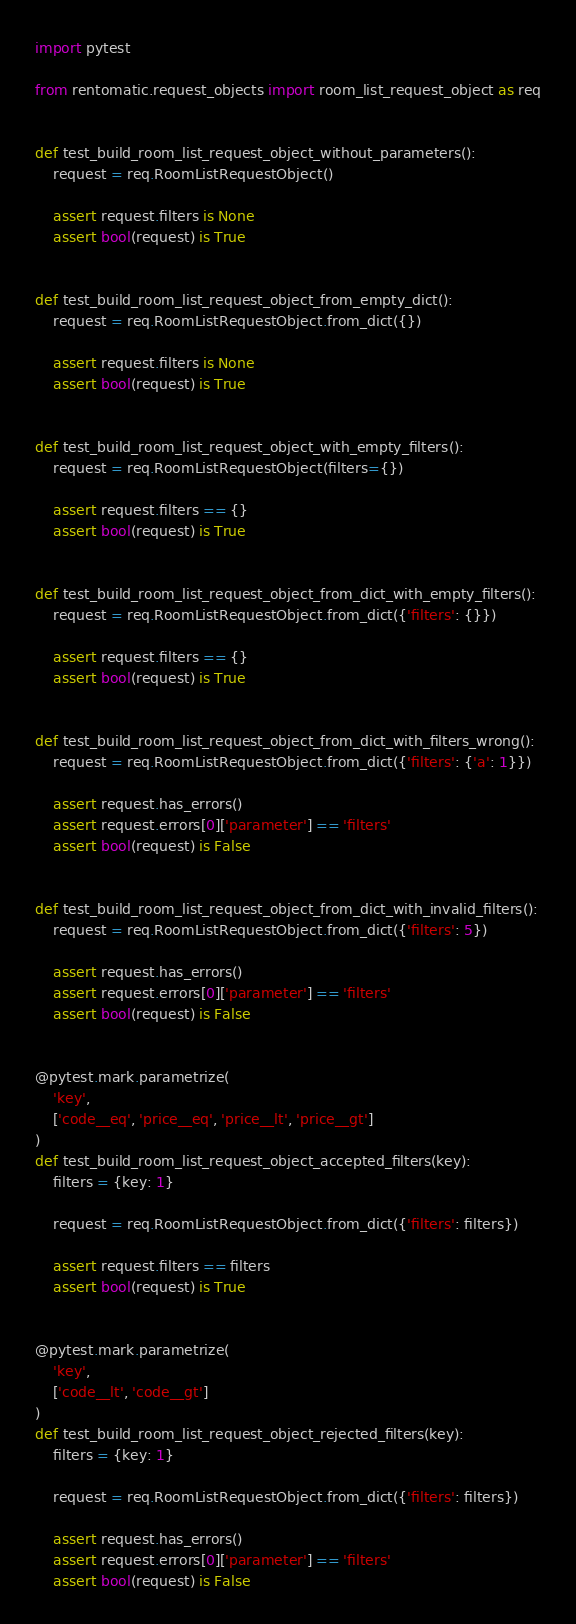Convert code to text. <code><loc_0><loc_0><loc_500><loc_500><_Python_>import pytest

from rentomatic.request_objects import room_list_request_object as req


def test_build_room_list_request_object_without_parameters():
    request = req.RoomListRequestObject()

    assert request.filters is None
    assert bool(request) is True


def test_build_room_list_request_object_from_empty_dict():
    request = req.RoomListRequestObject.from_dict({})

    assert request.filters is None
    assert bool(request) is True


def test_build_room_list_request_object_with_empty_filters():
    request = req.RoomListRequestObject(filters={})

    assert request.filters == {}
    assert bool(request) is True


def test_build_room_list_request_object_from_dict_with_empty_filters():
    request = req.RoomListRequestObject.from_dict({'filters': {}})

    assert request.filters == {}
    assert bool(request) is True


def test_build_room_list_request_object_from_dict_with_filters_wrong():
    request = req.RoomListRequestObject.from_dict({'filters': {'a': 1}})

    assert request.has_errors()
    assert request.errors[0]['parameter'] == 'filters'
    assert bool(request) is False


def test_build_room_list_request_object_from_dict_with_invalid_filters():
    request = req.RoomListRequestObject.from_dict({'filters': 5})

    assert request.has_errors()
    assert request.errors[0]['parameter'] == 'filters'
    assert bool(request) is False


@pytest.mark.parametrize(
    'key',
    ['code__eq', 'price__eq', 'price__lt', 'price__gt']
)
def test_build_room_list_request_object_accepted_filters(key):
    filters = {key: 1}

    request = req.RoomListRequestObject.from_dict({'filters': filters})

    assert request.filters == filters
    assert bool(request) is True


@pytest.mark.parametrize(
    'key',
    ['code__lt', 'code__gt']
)
def test_build_room_list_request_object_rejected_filters(key):
    filters = {key: 1}

    request = req.RoomListRequestObject.from_dict({'filters': filters})

    assert request.has_errors()
    assert request.errors[0]['parameter'] == 'filters'
    assert bool(request) is False
</code> 